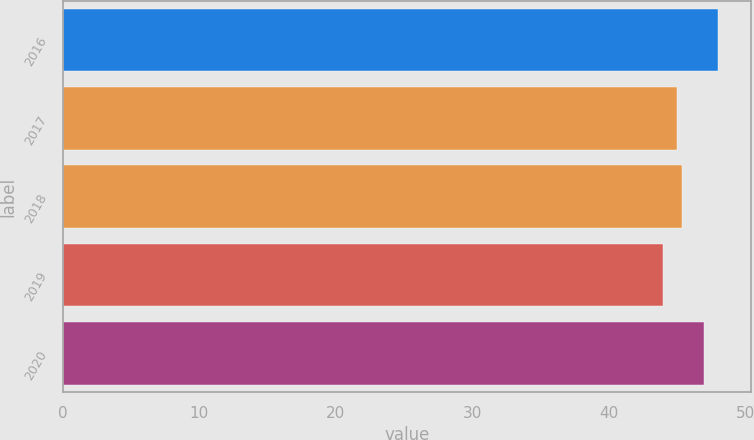<chart> <loc_0><loc_0><loc_500><loc_500><bar_chart><fcel>2016<fcel>2017<fcel>2018<fcel>2019<fcel>2020<nl><fcel>48<fcel>45<fcel>45.4<fcel>44<fcel>47<nl></chart> 